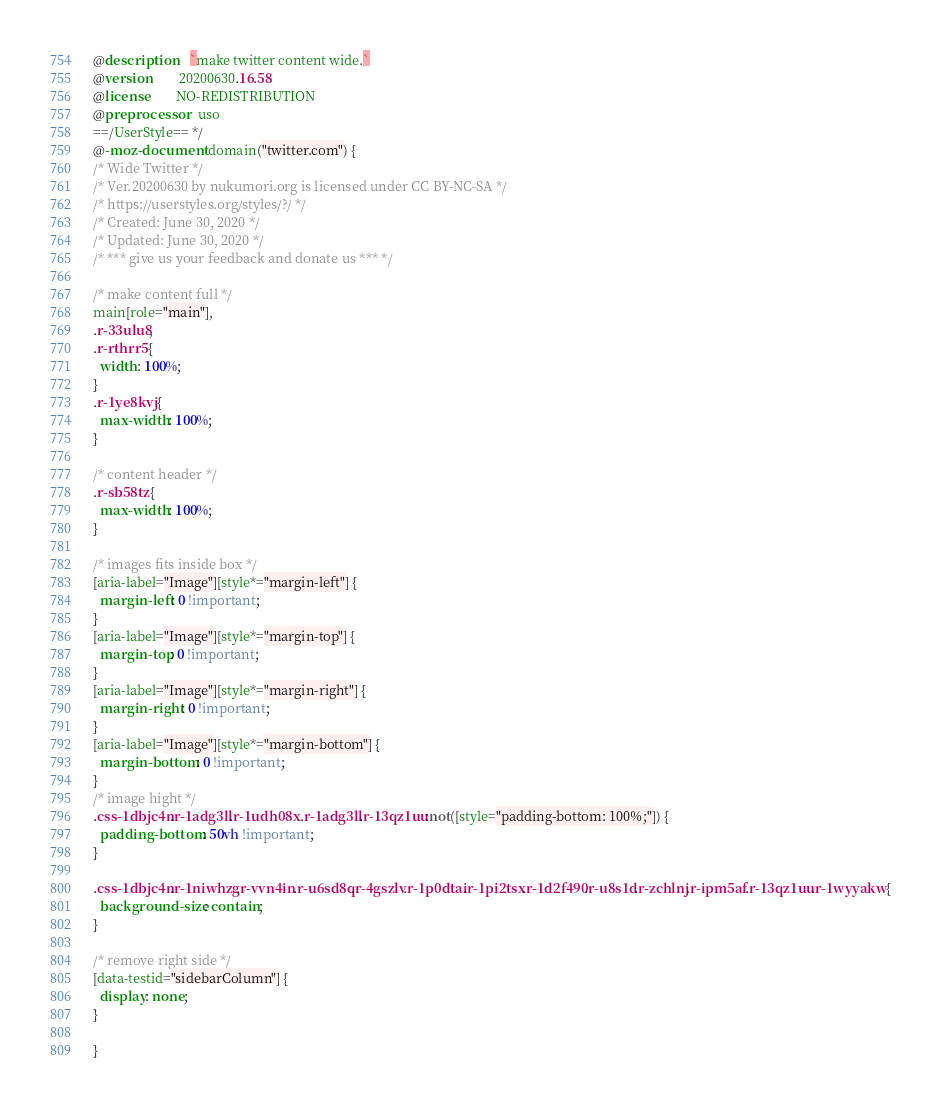<code> <loc_0><loc_0><loc_500><loc_500><_CSS_>@description    `make twitter content wide.`
@version        20200630.16.58
@license        NO-REDISTRIBUTION
@preprocessor   uso
==/UserStyle== */
@-moz-document domain("twitter.com") {
/* Wide Twitter */
/* Ver.20200630 by nukumori.org is licensed under CC BY-NC-SA */
/* https://userstyles.org/styles/?/ */
/* Created: June 30, 2020 */
/* Updated: June 30, 2020 */
/* *** give us your feedback and donate us *** */

/* make content full */
main[role="main"],
.r-33ulu8,
.r-rthrr5 {
  width: 100%;
}
.r-1ye8kvj {
  max-width: 100%;
}

/* content header */
.r-sb58tz {
  max-width: 100%;
}

/* images fits inside box */
[aria-label="Image"][style*="margin-left"] {
  margin-left: 0 !important;
}
[aria-label="Image"][style*="margin-top"] {
  margin-top: 0 !important;
}
[aria-label="Image"][style*="margin-right"] {
  margin-right: 0 !important;
}
[aria-label="Image"][style*="margin-bottom"] {
  margin-bottom: 0 !important;
}
/* image hight */
.css-1dbjc4n.r-1adg3ll.r-1udh08x .r-1adg3ll.r-13qz1uu:not([style="padding-bottom: 100%;"]) {
  padding-bottom: 50vh !important;
}

.css-1dbjc4n.r-1niwhzg.r-vvn4in.r-u6sd8q.r-4gszlv.r-1p0dtai.r-1pi2tsx.r-1d2f490.r-u8s1d.r-zchlnj.r-ipm5af.r-13qz1uu.r-1wyyakw {
  background-size: contain;
}

/* remove right side */
[data-testid="sidebarColumn"] {
  display: none;
}

}</code> 